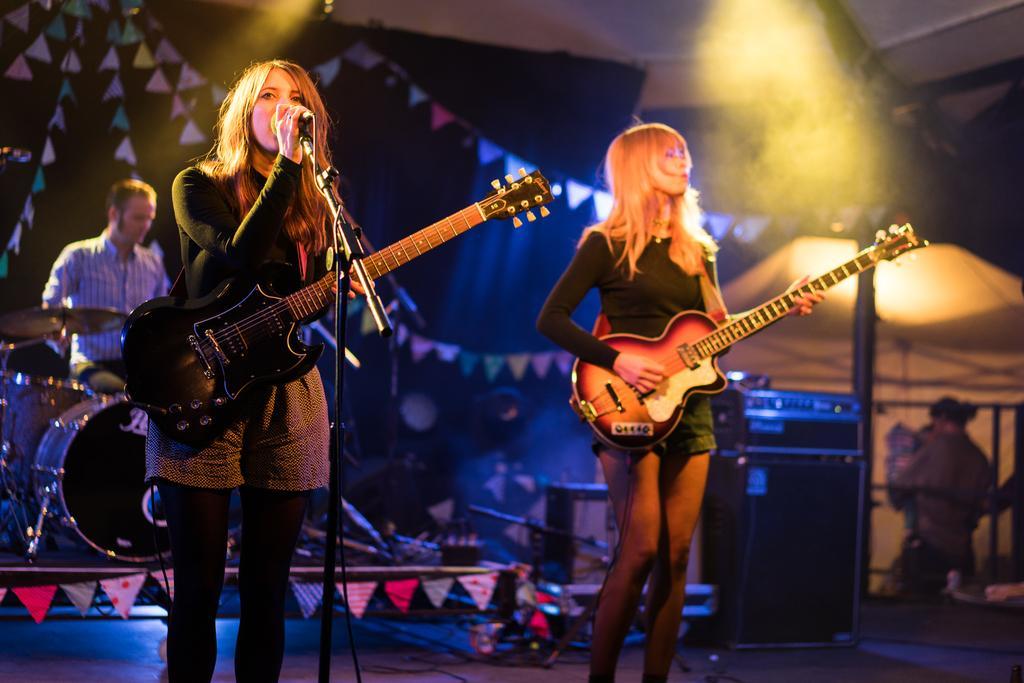How would you summarize this image in a sentence or two? In this picture we can see two women holding guitars in their hands and standing on stage and here woman singing on mic and at back of them man sitting and playing drums and in background we can see decorative flags, light. 